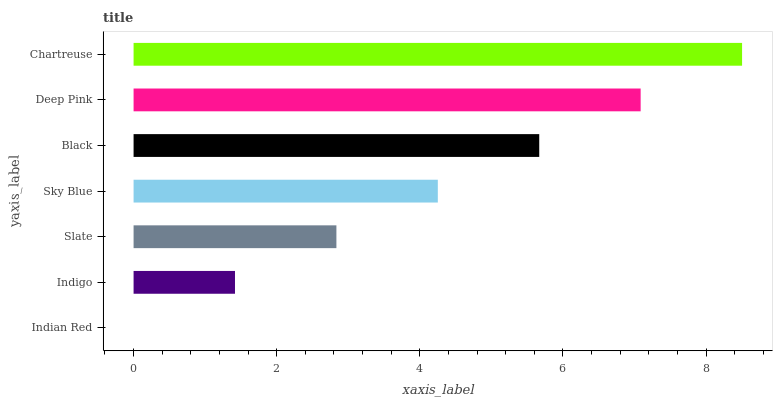Is Indian Red the minimum?
Answer yes or no. Yes. Is Chartreuse the maximum?
Answer yes or no. Yes. Is Indigo the minimum?
Answer yes or no. No. Is Indigo the maximum?
Answer yes or no. No. Is Indigo greater than Indian Red?
Answer yes or no. Yes. Is Indian Red less than Indigo?
Answer yes or no. Yes. Is Indian Red greater than Indigo?
Answer yes or no. No. Is Indigo less than Indian Red?
Answer yes or no. No. Is Sky Blue the high median?
Answer yes or no. Yes. Is Sky Blue the low median?
Answer yes or no. Yes. Is Deep Pink the high median?
Answer yes or no. No. Is Indian Red the low median?
Answer yes or no. No. 